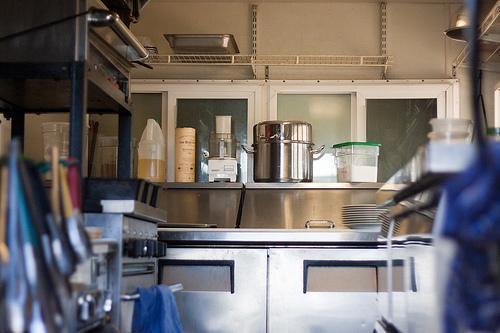How many large drawers are below, straight ahead?
Give a very brief answer. 2. 